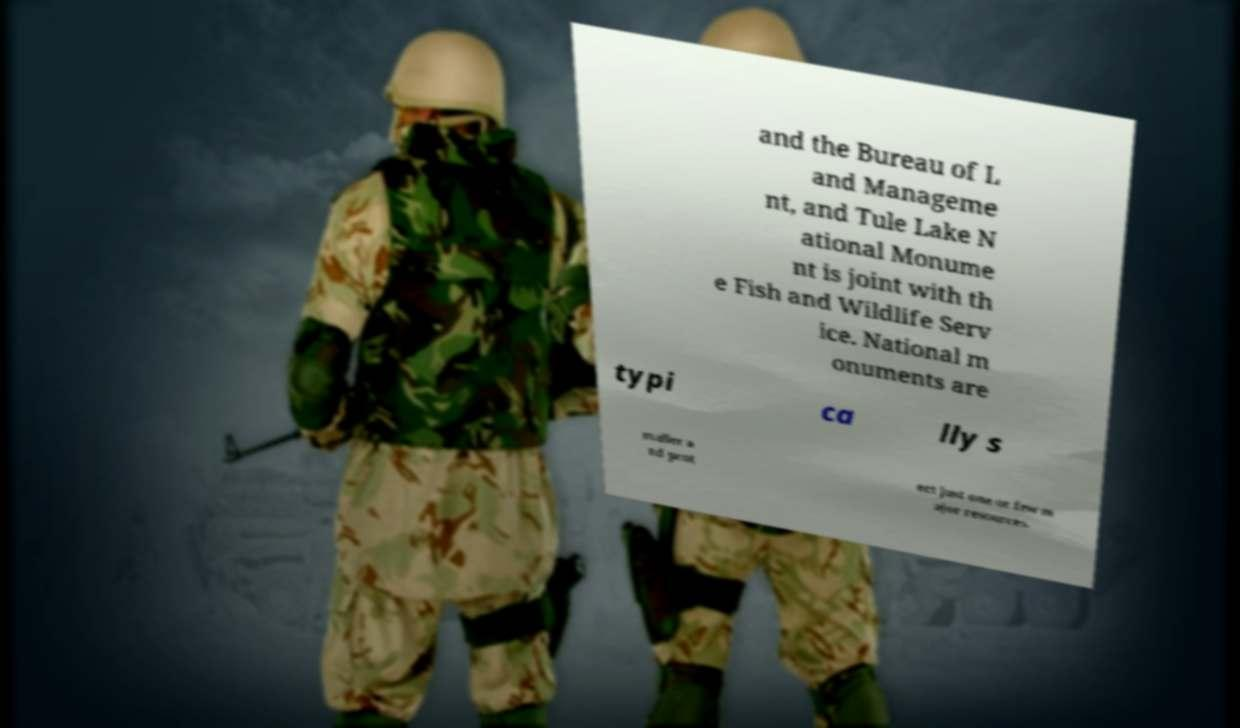Could you extract and type out the text from this image? and the Bureau of L and Manageme nt, and Tule Lake N ational Monume nt is joint with th e Fish and Wildlife Serv ice. National m onuments are typi ca lly s maller a nd prot ect just one or few m ajor resources. 